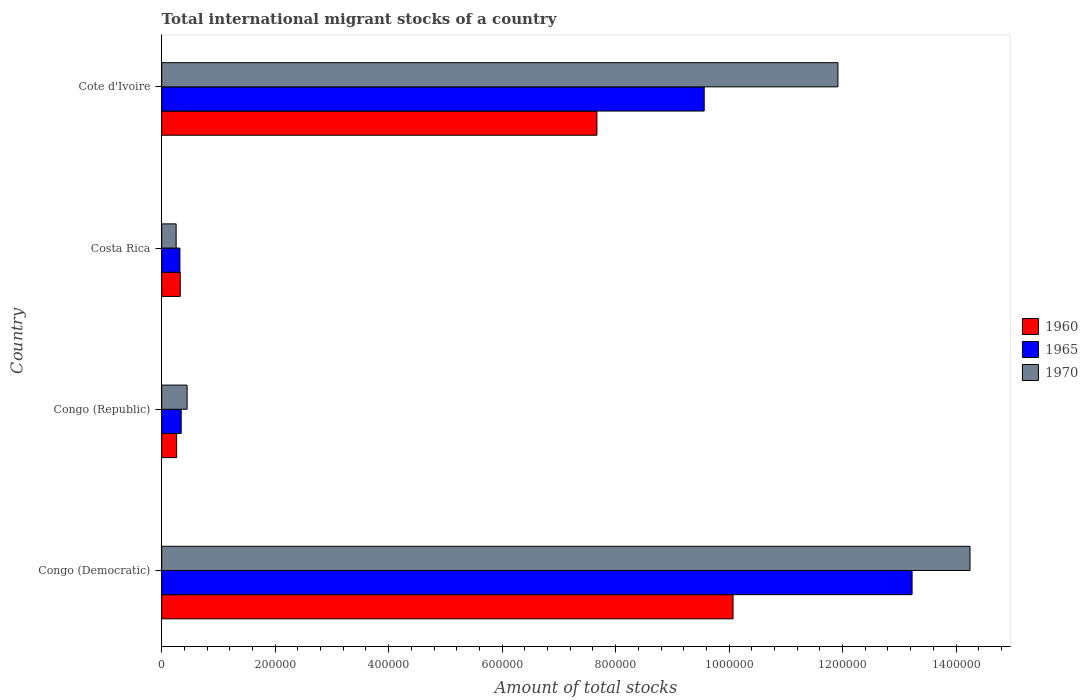How many different coloured bars are there?
Your answer should be very brief. 3. Are the number of bars per tick equal to the number of legend labels?
Offer a very short reply. Yes. How many bars are there on the 4th tick from the top?
Provide a succinct answer. 3. What is the label of the 2nd group of bars from the top?
Keep it short and to the point. Costa Rica. What is the amount of total stocks in in 1970 in Costa Rica?
Make the answer very short. 2.54e+04. Across all countries, what is the maximum amount of total stocks in in 1970?
Keep it short and to the point. 1.42e+06. Across all countries, what is the minimum amount of total stocks in in 1970?
Your response must be concise. 2.54e+04. In which country was the amount of total stocks in in 1970 maximum?
Give a very brief answer. Congo (Democratic). In which country was the amount of total stocks in in 1965 minimum?
Provide a succinct answer. Costa Rica. What is the total amount of total stocks in in 1965 in the graph?
Provide a succinct answer. 2.34e+06. What is the difference between the amount of total stocks in in 1970 in Congo (Democratic) and that in Cote d'Ivoire?
Offer a terse response. 2.33e+05. What is the difference between the amount of total stocks in in 1970 in Congo (Republic) and the amount of total stocks in in 1965 in Costa Rica?
Keep it short and to the point. 1.27e+04. What is the average amount of total stocks in in 1960 per country?
Your answer should be compact. 4.58e+05. What is the difference between the amount of total stocks in in 1960 and amount of total stocks in in 1965 in Costa Rica?
Make the answer very short. 620. What is the ratio of the amount of total stocks in in 1965 in Congo (Republic) to that in Costa Rica?
Ensure brevity in your answer.  1.07. Is the difference between the amount of total stocks in in 1960 in Congo (Democratic) and Cote d'Ivoire greater than the difference between the amount of total stocks in in 1965 in Congo (Democratic) and Cote d'Ivoire?
Your response must be concise. No. What is the difference between the highest and the second highest amount of total stocks in in 1965?
Your response must be concise. 3.66e+05. What is the difference between the highest and the lowest amount of total stocks in in 1970?
Give a very brief answer. 1.40e+06. Is the sum of the amount of total stocks in in 1970 in Congo (Democratic) and Costa Rica greater than the maximum amount of total stocks in in 1965 across all countries?
Keep it short and to the point. Yes. What does the 3rd bar from the top in Congo (Democratic) represents?
Give a very brief answer. 1960. What does the 3rd bar from the bottom in Congo (Democratic) represents?
Your answer should be compact. 1970. Is it the case that in every country, the sum of the amount of total stocks in in 1965 and amount of total stocks in in 1960 is greater than the amount of total stocks in in 1970?
Offer a terse response. Yes. How many bars are there?
Offer a very short reply. 12. Are the values on the major ticks of X-axis written in scientific E-notation?
Your response must be concise. No. Does the graph contain grids?
Make the answer very short. No. What is the title of the graph?
Keep it short and to the point. Total international migrant stocks of a country. What is the label or title of the X-axis?
Make the answer very short. Amount of total stocks. What is the Amount of total stocks in 1960 in Congo (Democratic)?
Ensure brevity in your answer.  1.01e+06. What is the Amount of total stocks in 1965 in Congo (Democratic)?
Offer a terse response. 1.32e+06. What is the Amount of total stocks of 1970 in Congo (Democratic)?
Provide a short and direct response. 1.42e+06. What is the Amount of total stocks of 1960 in Congo (Republic)?
Offer a very short reply. 2.63e+04. What is the Amount of total stocks of 1965 in Congo (Republic)?
Offer a terse response. 3.43e+04. What is the Amount of total stocks of 1970 in Congo (Republic)?
Provide a succinct answer. 4.48e+04. What is the Amount of total stocks of 1960 in Costa Rica?
Offer a very short reply. 3.27e+04. What is the Amount of total stocks of 1965 in Costa Rica?
Keep it short and to the point. 3.21e+04. What is the Amount of total stocks in 1970 in Costa Rica?
Your response must be concise. 2.54e+04. What is the Amount of total stocks in 1960 in Cote d'Ivoire?
Make the answer very short. 7.67e+05. What is the Amount of total stocks of 1965 in Cote d'Ivoire?
Offer a very short reply. 9.56e+05. What is the Amount of total stocks of 1970 in Cote d'Ivoire?
Your response must be concise. 1.19e+06. Across all countries, what is the maximum Amount of total stocks in 1960?
Give a very brief answer. 1.01e+06. Across all countries, what is the maximum Amount of total stocks of 1965?
Your answer should be very brief. 1.32e+06. Across all countries, what is the maximum Amount of total stocks in 1970?
Your answer should be very brief. 1.42e+06. Across all countries, what is the minimum Amount of total stocks of 1960?
Your answer should be compact. 2.63e+04. Across all countries, what is the minimum Amount of total stocks in 1965?
Offer a terse response. 3.21e+04. Across all countries, what is the minimum Amount of total stocks in 1970?
Make the answer very short. 2.54e+04. What is the total Amount of total stocks of 1960 in the graph?
Keep it short and to the point. 1.83e+06. What is the total Amount of total stocks of 1965 in the graph?
Offer a terse response. 2.34e+06. What is the total Amount of total stocks of 1970 in the graph?
Offer a terse response. 2.69e+06. What is the difference between the Amount of total stocks in 1960 in Congo (Democratic) and that in Congo (Republic)?
Ensure brevity in your answer.  9.81e+05. What is the difference between the Amount of total stocks of 1965 in Congo (Democratic) and that in Congo (Republic)?
Provide a succinct answer. 1.29e+06. What is the difference between the Amount of total stocks in 1970 in Congo (Democratic) and that in Congo (Republic)?
Make the answer very short. 1.38e+06. What is the difference between the Amount of total stocks of 1960 in Congo (Democratic) and that in Costa Rica?
Provide a succinct answer. 9.74e+05. What is the difference between the Amount of total stocks of 1965 in Congo (Democratic) and that in Costa Rica?
Your response must be concise. 1.29e+06. What is the difference between the Amount of total stocks of 1970 in Congo (Democratic) and that in Costa Rica?
Your response must be concise. 1.40e+06. What is the difference between the Amount of total stocks of 1960 in Congo (Democratic) and that in Cote d'Ivoire?
Your answer should be very brief. 2.40e+05. What is the difference between the Amount of total stocks in 1965 in Congo (Democratic) and that in Cote d'Ivoire?
Your answer should be very brief. 3.66e+05. What is the difference between the Amount of total stocks of 1970 in Congo (Democratic) and that in Cote d'Ivoire?
Your response must be concise. 2.33e+05. What is the difference between the Amount of total stocks in 1960 in Congo (Republic) and that in Costa Rica?
Give a very brief answer. -6378. What is the difference between the Amount of total stocks of 1965 in Congo (Republic) and that in Costa Rica?
Keep it short and to the point. 2251. What is the difference between the Amount of total stocks of 1970 in Congo (Republic) and that in Costa Rica?
Your answer should be compact. 1.93e+04. What is the difference between the Amount of total stocks in 1960 in Congo (Republic) and that in Cote d'Ivoire?
Your answer should be very brief. -7.41e+05. What is the difference between the Amount of total stocks of 1965 in Congo (Republic) and that in Cote d'Ivoire?
Offer a terse response. -9.22e+05. What is the difference between the Amount of total stocks in 1970 in Congo (Republic) and that in Cote d'Ivoire?
Provide a short and direct response. -1.15e+06. What is the difference between the Amount of total stocks in 1960 in Costa Rica and that in Cote d'Ivoire?
Provide a succinct answer. -7.34e+05. What is the difference between the Amount of total stocks in 1965 in Costa Rica and that in Cote d'Ivoire?
Your answer should be very brief. -9.24e+05. What is the difference between the Amount of total stocks in 1970 in Costa Rica and that in Cote d'Ivoire?
Your answer should be very brief. -1.17e+06. What is the difference between the Amount of total stocks in 1960 in Congo (Democratic) and the Amount of total stocks in 1965 in Congo (Republic)?
Keep it short and to the point. 9.73e+05. What is the difference between the Amount of total stocks in 1960 in Congo (Democratic) and the Amount of total stocks in 1970 in Congo (Republic)?
Provide a short and direct response. 9.62e+05. What is the difference between the Amount of total stocks of 1965 in Congo (Democratic) and the Amount of total stocks of 1970 in Congo (Republic)?
Offer a very short reply. 1.28e+06. What is the difference between the Amount of total stocks in 1960 in Congo (Democratic) and the Amount of total stocks in 1965 in Costa Rica?
Make the answer very short. 9.75e+05. What is the difference between the Amount of total stocks in 1960 in Congo (Democratic) and the Amount of total stocks in 1970 in Costa Rica?
Your answer should be very brief. 9.81e+05. What is the difference between the Amount of total stocks in 1965 in Congo (Democratic) and the Amount of total stocks in 1970 in Costa Rica?
Ensure brevity in your answer.  1.30e+06. What is the difference between the Amount of total stocks in 1960 in Congo (Democratic) and the Amount of total stocks in 1965 in Cote d'Ivoire?
Offer a very short reply. 5.08e+04. What is the difference between the Amount of total stocks of 1960 in Congo (Democratic) and the Amount of total stocks of 1970 in Cote d'Ivoire?
Give a very brief answer. -1.85e+05. What is the difference between the Amount of total stocks of 1965 in Congo (Democratic) and the Amount of total stocks of 1970 in Cote d'Ivoire?
Give a very brief answer. 1.31e+05. What is the difference between the Amount of total stocks of 1960 in Congo (Republic) and the Amount of total stocks of 1965 in Costa Rica?
Your response must be concise. -5758. What is the difference between the Amount of total stocks in 1960 in Congo (Republic) and the Amount of total stocks in 1970 in Costa Rica?
Make the answer very short. 883. What is the difference between the Amount of total stocks of 1965 in Congo (Republic) and the Amount of total stocks of 1970 in Costa Rica?
Your answer should be very brief. 8892. What is the difference between the Amount of total stocks in 1960 in Congo (Republic) and the Amount of total stocks in 1965 in Cote d'Ivoire?
Your answer should be compact. -9.30e+05. What is the difference between the Amount of total stocks of 1960 in Congo (Republic) and the Amount of total stocks of 1970 in Cote d'Ivoire?
Your answer should be very brief. -1.17e+06. What is the difference between the Amount of total stocks in 1965 in Congo (Republic) and the Amount of total stocks in 1970 in Cote d'Ivoire?
Ensure brevity in your answer.  -1.16e+06. What is the difference between the Amount of total stocks of 1960 in Costa Rica and the Amount of total stocks of 1965 in Cote d'Ivoire?
Make the answer very short. -9.23e+05. What is the difference between the Amount of total stocks in 1960 in Costa Rica and the Amount of total stocks in 1970 in Cote d'Ivoire?
Your answer should be compact. -1.16e+06. What is the difference between the Amount of total stocks of 1965 in Costa Rica and the Amount of total stocks of 1970 in Cote d'Ivoire?
Provide a succinct answer. -1.16e+06. What is the average Amount of total stocks in 1960 per country?
Make the answer very short. 4.58e+05. What is the average Amount of total stocks in 1965 per country?
Your answer should be compact. 5.86e+05. What is the average Amount of total stocks of 1970 per country?
Give a very brief answer. 6.72e+05. What is the difference between the Amount of total stocks of 1960 and Amount of total stocks of 1965 in Congo (Democratic)?
Offer a terse response. -3.16e+05. What is the difference between the Amount of total stocks in 1960 and Amount of total stocks in 1970 in Congo (Democratic)?
Provide a succinct answer. -4.18e+05. What is the difference between the Amount of total stocks in 1965 and Amount of total stocks in 1970 in Congo (Democratic)?
Provide a short and direct response. -1.02e+05. What is the difference between the Amount of total stocks of 1960 and Amount of total stocks of 1965 in Congo (Republic)?
Your response must be concise. -8009. What is the difference between the Amount of total stocks of 1960 and Amount of total stocks of 1970 in Congo (Republic)?
Ensure brevity in your answer.  -1.85e+04. What is the difference between the Amount of total stocks in 1965 and Amount of total stocks in 1970 in Congo (Republic)?
Your response must be concise. -1.04e+04. What is the difference between the Amount of total stocks in 1960 and Amount of total stocks in 1965 in Costa Rica?
Offer a very short reply. 620. What is the difference between the Amount of total stocks of 1960 and Amount of total stocks of 1970 in Costa Rica?
Provide a succinct answer. 7261. What is the difference between the Amount of total stocks of 1965 and Amount of total stocks of 1970 in Costa Rica?
Your answer should be very brief. 6641. What is the difference between the Amount of total stocks in 1960 and Amount of total stocks in 1965 in Cote d'Ivoire?
Your answer should be very brief. -1.89e+05. What is the difference between the Amount of total stocks in 1960 and Amount of total stocks in 1970 in Cote d'Ivoire?
Keep it short and to the point. -4.25e+05. What is the difference between the Amount of total stocks in 1965 and Amount of total stocks in 1970 in Cote d'Ivoire?
Ensure brevity in your answer.  -2.36e+05. What is the ratio of the Amount of total stocks of 1960 in Congo (Democratic) to that in Congo (Republic)?
Give a very brief answer. 38.26. What is the ratio of the Amount of total stocks of 1965 in Congo (Democratic) to that in Congo (Republic)?
Offer a terse response. 38.53. What is the ratio of the Amount of total stocks in 1970 in Congo (Democratic) to that in Congo (Republic)?
Your response must be concise. 31.82. What is the ratio of the Amount of total stocks in 1960 in Congo (Democratic) to that in Costa Rica?
Make the answer very short. 30.8. What is the ratio of the Amount of total stocks in 1965 in Congo (Democratic) to that in Costa Rica?
Your answer should be very brief. 41.23. What is the ratio of the Amount of total stocks in 1970 in Congo (Democratic) to that in Costa Rica?
Provide a short and direct response. 56.02. What is the ratio of the Amount of total stocks of 1960 in Congo (Democratic) to that in Cote d'Ivoire?
Make the answer very short. 1.31. What is the ratio of the Amount of total stocks of 1965 in Congo (Democratic) to that in Cote d'Ivoire?
Your answer should be compact. 1.38. What is the ratio of the Amount of total stocks of 1970 in Congo (Democratic) to that in Cote d'Ivoire?
Give a very brief answer. 1.2. What is the ratio of the Amount of total stocks in 1960 in Congo (Republic) to that in Costa Rica?
Make the answer very short. 0.8. What is the ratio of the Amount of total stocks in 1965 in Congo (Republic) to that in Costa Rica?
Make the answer very short. 1.07. What is the ratio of the Amount of total stocks of 1970 in Congo (Republic) to that in Costa Rica?
Provide a short and direct response. 1.76. What is the ratio of the Amount of total stocks in 1960 in Congo (Republic) to that in Cote d'Ivoire?
Provide a short and direct response. 0.03. What is the ratio of the Amount of total stocks in 1965 in Congo (Republic) to that in Cote d'Ivoire?
Your answer should be compact. 0.04. What is the ratio of the Amount of total stocks in 1970 in Congo (Republic) to that in Cote d'Ivoire?
Provide a short and direct response. 0.04. What is the ratio of the Amount of total stocks of 1960 in Costa Rica to that in Cote d'Ivoire?
Your answer should be very brief. 0.04. What is the ratio of the Amount of total stocks of 1965 in Costa Rica to that in Cote d'Ivoire?
Give a very brief answer. 0.03. What is the ratio of the Amount of total stocks of 1970 in Costa Rica to that in Cote d'Ivoire?
Provide a short and direct response. 0.02. What is the difference between the highest and the second highest Amount of total stocks in 1960?
Your answer should be compact. 2.40e+05. What is the difference between the highest and the second highest Amount of total stocks in 1965?
Your response must be concise. 3.66e+05. What is the difference between the highest and the second highest Amount of total stocks of 1970?
Provide a short and direct response. 2.33e+05. What is the difference between the highest and the lowest Amount of total stocks in 1960?
Provide a succinct answer. 9.81e+05. What is the difference between the highest and the lowest Amount of total stocks in 1965?
Make the answer very short. 1.29e+06. What is the difference between the highest and the lowest Amount of total stocks of 1970?
Offer a terse response. 1.40e+06. 